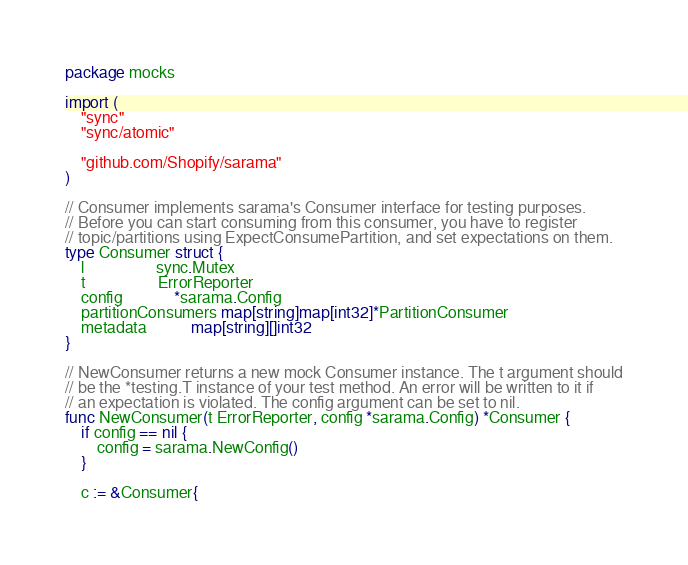<code> <loc_0><loc_0><loc_500><loc_500><_Go_>package mocks

import (
	"sync"
	"sync/atomic"

	"github.com/Shopify/sarama"
)

// Consumer implements sarama's Consumer interface for testing purposes.
// Before you can start consuming from this consumer, you have to register
// topic/partitions using ExpectConsumePartition, and set expectations on them.
type Consumer struct {
	l                  sync.Mutex
	t                  ErrorReporter
	config             *sarama.Config
	partitionConsumers map[string]map[int32]*PartitionConsumer
	metadata           map[string][]int32
}

// NewConsumer returns a new mock Consumer instance. The t argument should
// be the *testing.T instance of your test method. An error will be written to it if
// an expectation is violated. The config argument can be set to nil.
func NewConsumer(t ErrorReporter, config *sarama.Config) *Consumer {
	if config == nil {
		config = sarama.NewConfig()
	}

	c := &Consumer{</code> 